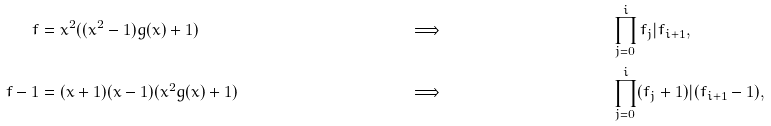<formula> <loc_0><loc_0><loc_500><loc_500>f & = x ^ { 2 } ( ( x ^ { 2 } - 1 ) g ( x ) + 1 ) & & \Longrightarrow & & \prod _ { j = 0 } ^ { i } f _ { j } | f _ { i + 1 } , \\ f - 1 & = ( x + 1 ) ( x - 1 ) ( x ^ { 2 } g ( x ) + 1 ) & & \Longrightarrow & & \prod _ { j = 0 } ^ { i } ( f _ { j } + 1 ) | ( f _ { i + 1 } - 1 ) ,</formula> 